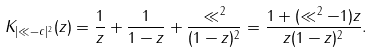Convert formula to latex. <formula><loc_0><loc_0><loc_500><loc_500>K _ { | \ll - c | ^ { 2 } } ( z ) = \frac { 1 } { z } + \frac { 1 } { 1 - z } + \frac { \ll ^ { 2 } } { ( 1 - z ) ^ { 2 } } = \frac { 1 + ( \ll ^ { 2 } - 1 ) z } { z ( 1 - z ) ^ { 2 } } .</formula> 